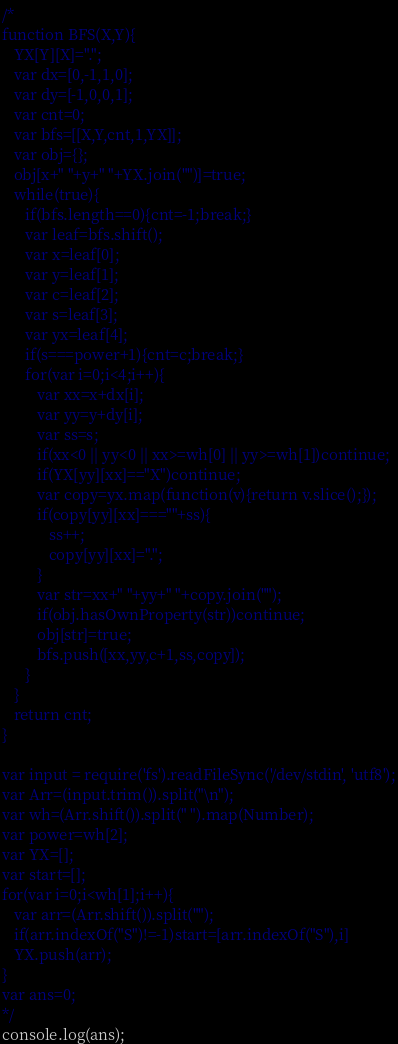Convert code to text. <code><loc_0><loc_0><loc_500><loc_500><_JavaScript_>/*
function BFS(X,Y){
   YX[Y][X]=".";
   var dx=[0,-1,1,0];
   var dy=[-1,0,0,1];
   var cnt=0;
   var bfs=[[X,Y,cnt,1,YX]];
   var obj={};
   obj[x+" "+y+" "+YX.join("")]=true;
   while(true){
      if(bfs.length==0){cnt=-1;break;}
      var leaf=bfs.shift();
      var x=leaf[0];
      var y=leaf[1];
      var c=leaf[2];
      var s=leaf[3];
      var yx=leaf[4];
      if(s===power+1){cnt=c;break;}
      for(var i=0;i<4;i++){
         var xx=x+dx[i];
         var yy=y+dy[i];
         var ss=s;
         if(xx<0 || yy<0 || xx>=wh[0] || yy>=wh[1])continue;
         if(YX[yy][xx]=="X")continue;
         var copy=yx.map(function(v){return v.slice();});
         if(copy[yy][xx]===""+ss){
            ss++;
            copy[yy][xx]=".";
         }
         var str=xx+" "+yy+" "+copy.join("");
         if(obj.hasOwnProperty(str))continue;
         obj[str]=true;
         bfs.push([xx,yy,c+1,ss,copy]);
      }
   }
   return cnt;
}

var input = require('fs').readFileSync('/dev/stdin', 'utf8');
var Arr=(input.trim()).split("\n");
var wh=(Arr.shift()).split(" ").map(Number);
var power=wh[2];
var YX=[];
var start=[];
for(var i=0;i<wh[1];i++){
   var arr=(Arr.shift()).split("");
   if(arr.indexOf("S")!=-1)start=[arr.indexOf("S"),i]
   YX.push(arr);
}
var ans=0;
*/
console.log(ans);</code> 